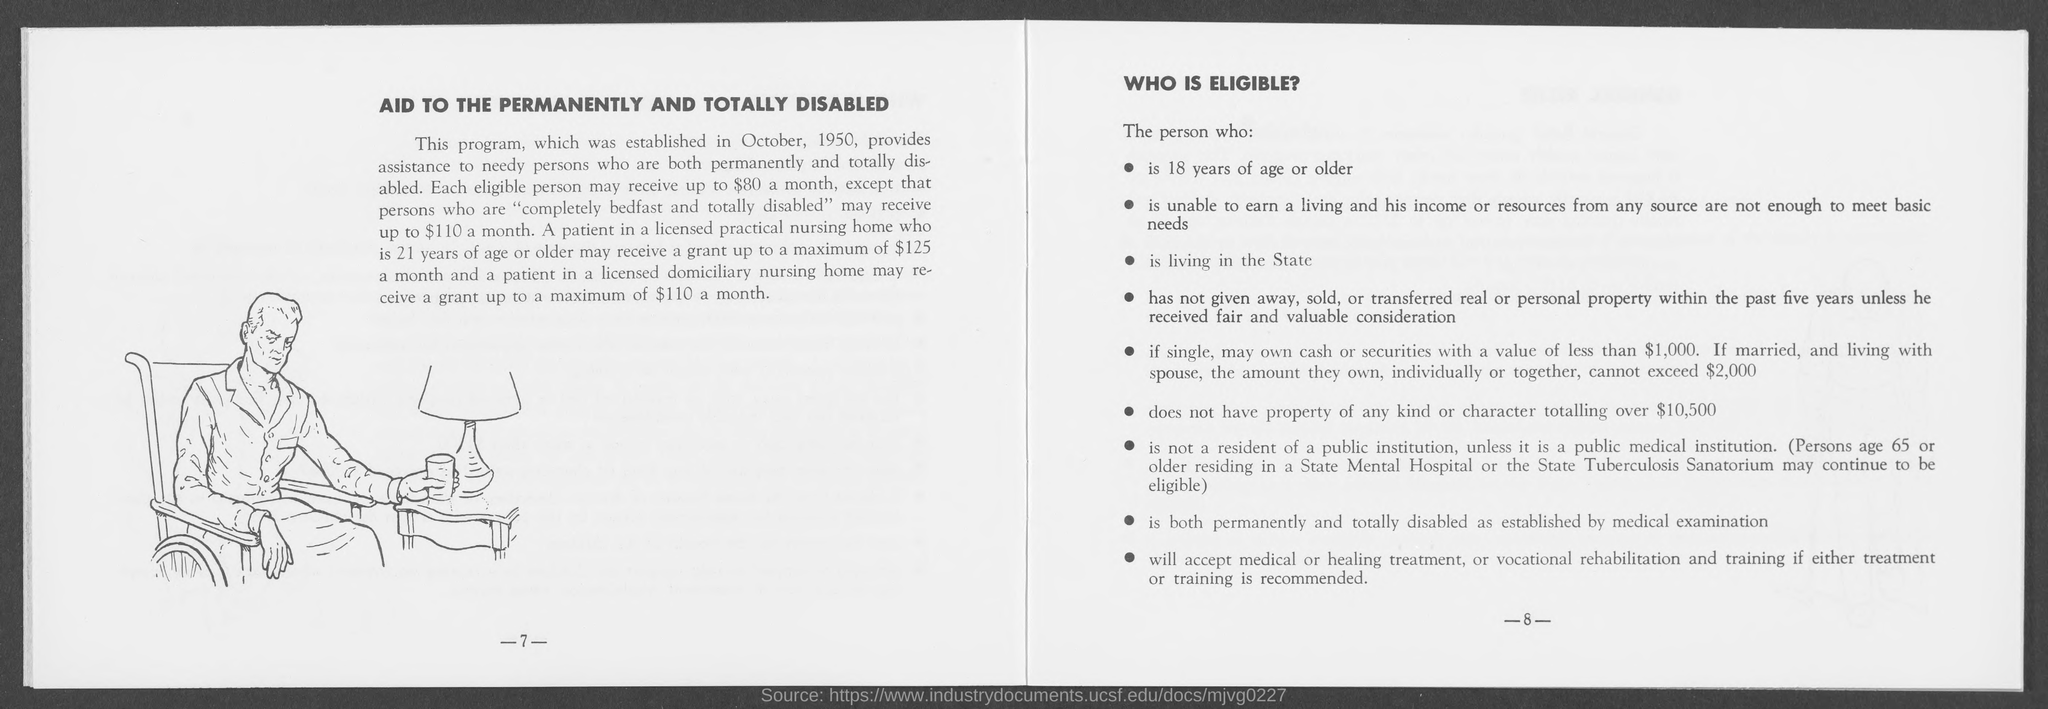When was the program established?
Make the answer very short. OCTOBER, 1950. How much will each person receive a month except totally disabled?
Your answer should be very brief. $80. Who can receive up to $110 a month?
Make the answer very short. PERSONS WHO ARE "COMPLETELY BEDFAST AND TOTALLY DISABLED". How much property of any kind or character should not be with the eligible person?
Make the answer very short. Over $10,500. 